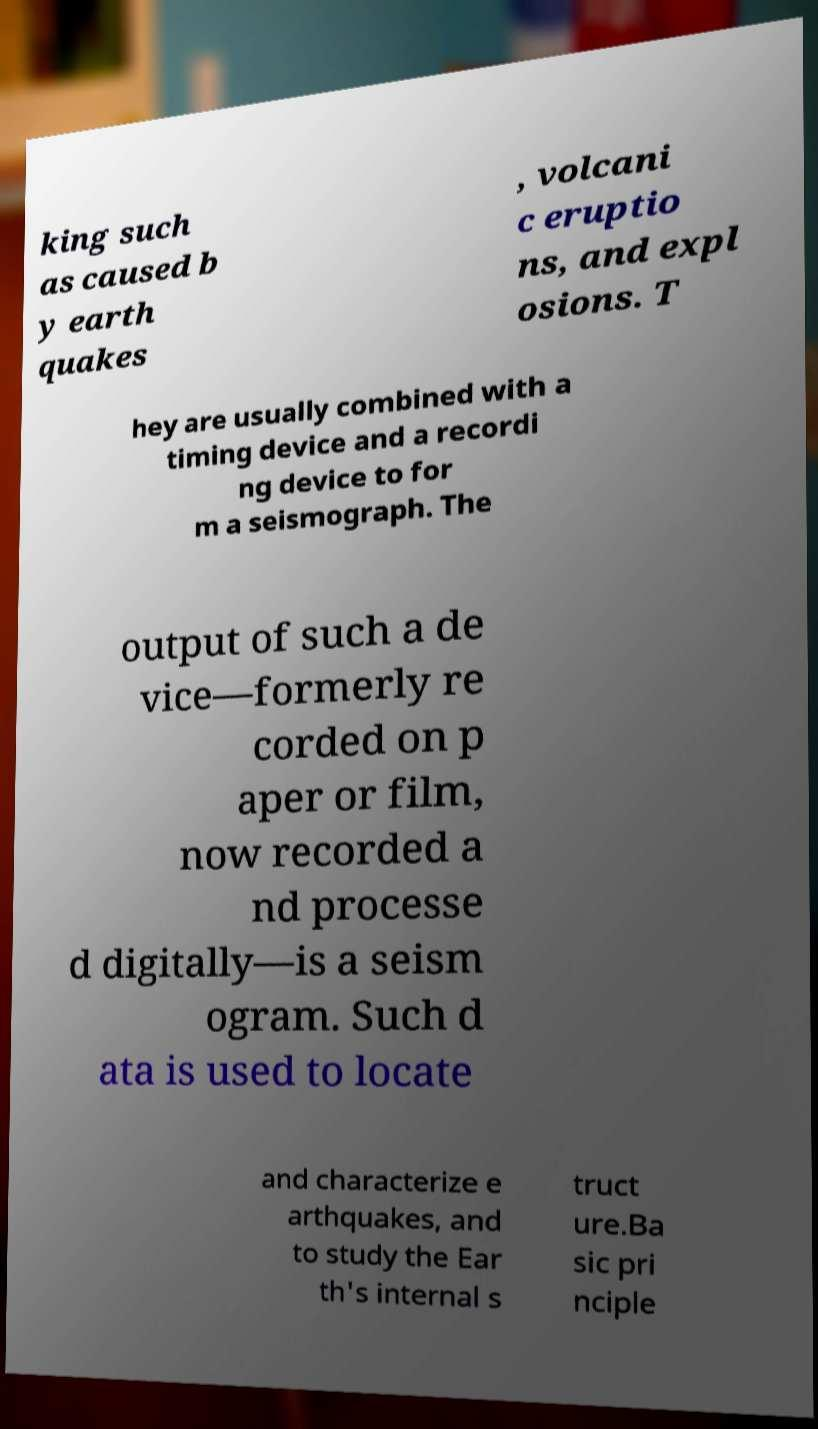What messages or text are displayed in this image? I need them in a readable, typed format. king such as caused b y earth quakes , volcani c eruptio ns, and expl osions. T hey are usually combined with a timing device and a recordi ng device to for m a seismograph. The output of such a de vice—formerly re corded on p aper or film, now recorded a nd processe d digitally—is a seism ogram. Such d ata is used to locate and characterize e arthquakes, and to study the Ear th's internal s truct ure.Ba sic pri nciple 